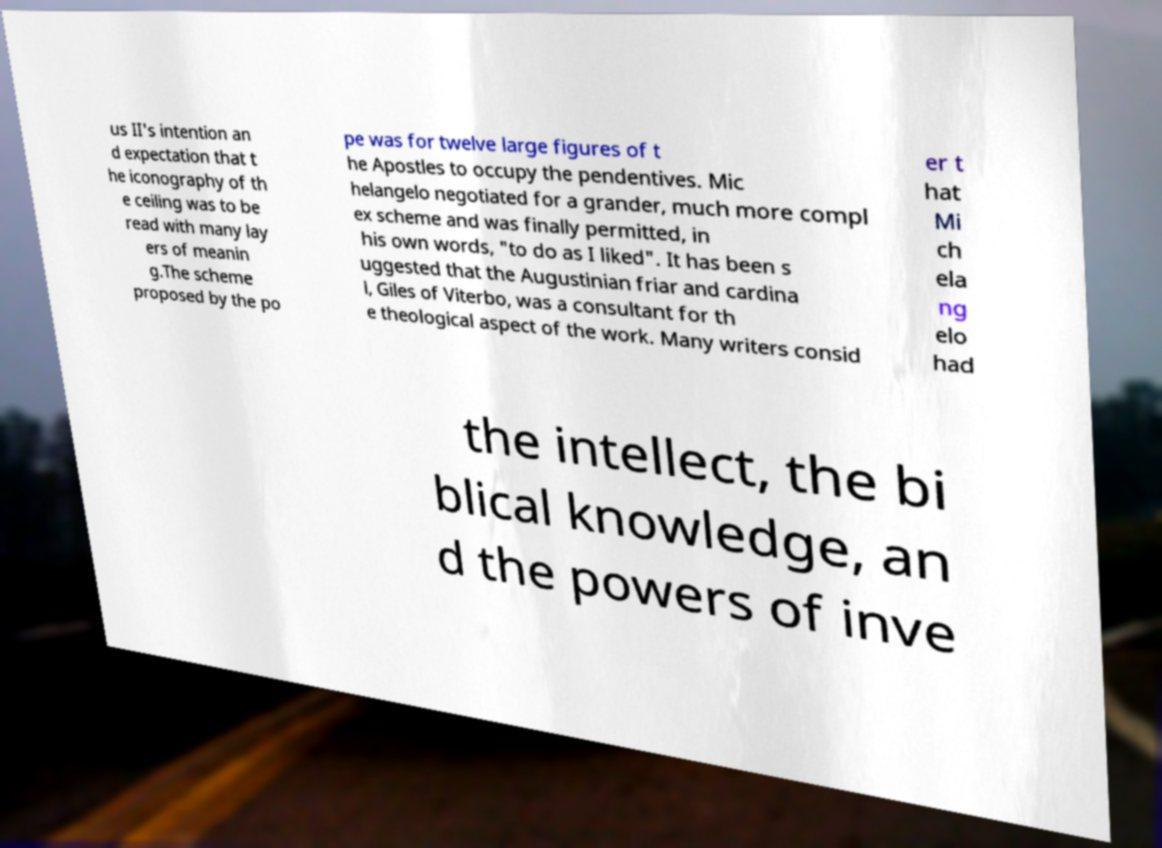Could you assist in decoding the text presented in this image and type it out clearly? us II's intention an d expectation that t he iconography of th e ceiling was to be read with many lay ers of meanin g.The scheme proposed by the po pe was for twelve large figures of t he Apostles to occupy the pendentives. Mic helangelo negotiated for a grander, much more compl ex scheme and was finally permitted, in his own words, "to do as I liked". It has been s uggested that the Augustinian friar and cardina l, Giles of Viterbo, was a consultant for th e theological aspect of the work. Many writers consid er t hat Mi ch ela ng elo had the intellect, the bi blical knowledge, an d the powers of inve 